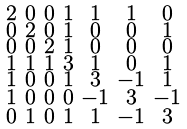Convert formula to latex. <formula><loc_0><loc_0><loc_500><loc_500>\begin{smallmatrix} 2 & 0 & 0 & 1 & 1 & 1 & 0 \\ 0 & 2 & 0 & 1 & 0 & 0 & 1 \\ 0 & 0 & 2 & 1 & 0 & 0 & 0 \\ 1 & 1 & 1 & 3 & 1 & 0 & 1 \\ 1 & 0 & 0 & 1 & 3 & - 1 & 1 \\ 1 & 0 & 0 & 0 & - 1 & 3 & - 1 \\ 0 & 1 & 0 & 1 & 1 & - 1 & 3 \end{smallmatrix}</formula> 